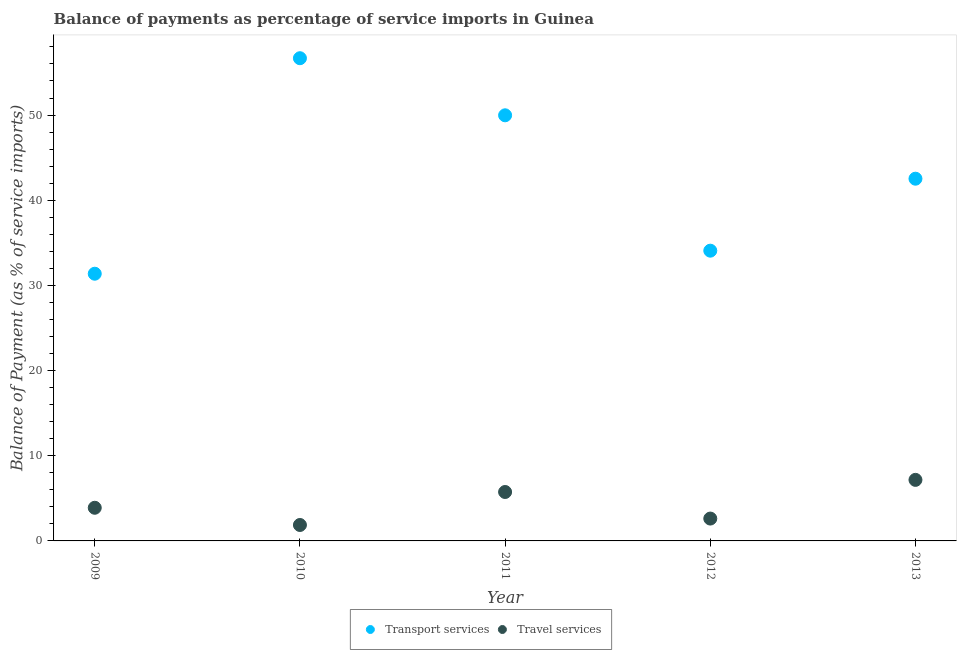How many different coloured dotlines are there?
Provide a short and direct response. 2. What is the balance of payments of transport services in 2011?
Offer a very short reply. 49.97. Across all years, what is the maximum balance of payments of travel services?
Offer a terse response. 7.17. Across all years, what is the minimum balance of payments of transport services?
Offer a terse response. 31.37. In which year was the balance of payments of travel services minimum?
Ensure brevity in your answer.  2010. What is the total balance of payments of transport services in the graph?
Keep it short and to the point. 214.62. What is the difference between the balance of payments of travel services in 2011 and that in 2012?
Your response must be concise. 3.12. What is the difference between the balance of payments of travel services in 2010 and the balance of payments of transport services in 2009?
Your answer should be compact. -29.5. What is the average balance of payments of transport services per year?
Keep it short and to the point. 42.92. In the year 2011, what is the difference between the balance of payments of transport services and balance of payments of travel services?
Ensure brevity in your answer.  44.23. What is the ratio of the balance of payments of transport services in 2009 to that in 2010?
Your response must be concise. 0.55. Is the balance of payments of travel services in 2010 less than that in 2011?
Give a very brief answer. Yes. What is the difference between the highest and the second highest balance of payments of transport services?
Give a very brief answer. 6.7. What is the difference between the highest and the lowest balance of payments of transport services?
Keep it short and to the point. 25.3. In how many years, is the balance of payments of transport services greater than the average balance of payments of transport services taken over all years?
Your answer should be compact. 2. Is the sum of the balance of payments of travel services in 2009 and 2010 greater than the maximum balance of payments of transport services across all years?
Your answer should be compact. No. How many dotlines are there?
Offer a terse response. 2. What is the difference between two consecutive major ticks on the Y-axis?
Your response must be concise. 10. Does the graph contain any zero values?
Offer a very short reply. No. Where does the legend appear in the graph?
Give a very brief answer. Bottom center. How many legend labels are there?
Ensure brevity in your answer.  2. What is the title of the graph?
Give a very brief answer. Balance of payments as percentage of service imports in Guinea. Does "Secondary" appear as one of the legend labels in the graph?
Make the answer very short. No. What is the label or title of the X-axis?
Your answer should be very brief. Year. What is the label or title of the Y-axis?
Provide a short and direct response. Balance of Payment (as % of service imports). What is the Balance of Payment (as % of service imports) of Transport services in 2009?
Keep it short and to the point. 31.37. What is the Balance of Payment (as % of service imports) of Travel services in 2009?
Offer a terse response. 3.89. What is the Balance of Payment (as % of service imports) of Transport services in 2010?
Offer a terse response. 56.67. What is the Balance of Payment (as % of service imports) in Travel services in 2010?
Provide a short and direct response. 1.87. What is the Balance of Payment (as % of service imports) of Transport services in 2011?
Ensure brevity in your answer.  49.97. What is the Balance of Payment (as % of service imports) of Travel services in 2011?
Your response must be concise. 5.74. What is the Balance of Payment (as % of service imports) of Transport services in 2012?
Offer a very short reply. 34.08. What is the Balance of Payment (as % of service imports) of Travel services in 2012?
Provide a succinct answer. 2.63. What is the Balance of Payment (as % of service imports) in Transport services in 2013?
Offer a very short reply. 42.53. What is the Balance of Payment (as % of service imports) of Travel services in 2013?
Make the answer very short. 7.17. Across all years, what is the maximum Balance of Payment (as % of service imports) in Transport services?
Your answer should be very brief. 56.67. Across all years, what is the maximum Balance of Payment (as % of service imports) of Travel services?
Provide a succinct answer. 7.17. Across all years, what is the minimum Balance of Payment (as % of service imports) in Transport services?
Keep it short and to the point. 31.37. Across all years, what is the minimum Balance of Payment (as % of service imports) of Travel services?
Offer a very short reply. 1.87. What is the total Balance of Payment (as % of service imports) in Transport services in the graph?
Offer a terse response. 214.62. What is the total Balance of Payment (as % of service imports) of Travel services in the graph?
Your answer should be very brief. 21.3. What is the difference between the Balance of Payment (as % of service imports) of Transport services in 2009 and that in 2010?
Offer a very short reply. -25.3. What is the difference between the Balance of Payment (as % of service imports) of Travel services in 2009 and that in 2010?
Offer a terse response. 2.02. What is the difference between the Balance of Payment (as % of service imports) of Transport services in 2009 and that in 2011?
Offer a very short reply. -18.6. What is the difference between the Balance of Payment (as % of service imports) of Travel services in 2009 and that in 2011?
Your answer should be compact. -1.85. What is the difference between the Balance of Payment (as % of service imports) of Transport services in 2009 and that in 2012?
Give a very brief answer. -2.71. What is the difference between the Balance of Payment (as % of service imports) of Travel services in 2009 and that in 2012?
Provide a succinct answer. 1.27. What is the difference between the Balance of Payment (as % of service imports) in Transport services in 2009 and that in 2013?
Your response must be concise. -11.16. What is the difference between the Balance of Payment (as % of service imports) in Travel services in 2009 and that in 2013?
Ensure brevity in your answer.  -3.27. What is the difference between the Balance of Payment (as % of service imports) of Transport services in 2010 and that in 2011?
Give a very brief answer. 6.7. What is the difference between the Balance of Payment (as % of service imports) of Travel services in 2010 and that in 2011?
Offer a very short reply. -3.87. What is the difference between the Balance of Payment (as % of service imports) in Transport services in 2010 and that in 2012?
Ensure brevity in your answer.  22.6. What is the difference between the Balance of Payment (as % of service imports) of Travel services in 2010 and that in 2012?
Make the answer very short. -0.75. What is the difference between the Balance of Payment (as % of service imports) of Transport services in 2010 and that in 2013?
Your answer should be very brief. 14.15. What is the difference between the Balance of Payment (as % of service imports) of Travel services in 2010 and that in 2013?
Keep it short and to the point. -5.3. What is the difference between the Balance of Payment (as % of service imports) in Transport services in 2011 and that in 2012?
Your answer should be compact. 15.89. What is the difference between the Balance of Payment (as % of service imports) in Travel services in 2011 and that in 2012?
Provide a succinct answer. 3.12. What is the difference between the Balance of Payment (as % of service imports) in Transport services in 2011 and that in 2013?
Your answer should be very brief. 7.44. What is the difference between the Balance of Payment (as % of service imports) in Travel services in 2011 and that in 2013?
Give a very brief answer. -1.42. What is the difference between the Balance of Payment (as % of service imports) in Transport services in 2012 and that in 2013?
Your answer should be compact. -8.45. What is the difference between the Balance of Payment (as % of service imports) of Travel services in 2012 and that in 2013?
Offer a terse response. -4.54. What is the difference between the Balance of Payment (as % of service imports) in Transport services in 2009 and the Balance of Payment (as % of service imports) in Travel services in 2010?
Ensure brevity in your answer.  29.5. What is the difference between the Balance of Payment (as % of service imports) in Transport services in 2009 and the Balance of Payment (as % of service imports) in Travel services in 2011?
Give a very brief answer. 25.63. What is the difference between the Balance of Payment (as % of service imports) in Transport services in 2009 and the Balance of Payment (as % of service imports) in Travel services in 2012?
Provide a succinct answer. 28.75. What is the difference between the Balance of Payment (as % of service imports) of Transport services in 2009 and the Balance of Payment (as % of service imports) of Travel services in 2013?
Provide a short and direct response. 24.2. What is the difference between the Balance of Payment (as % of service imports) of Transport services in 2010 and the Balance of Payment (as % of service imports) of Travel services in 2011?
Your answer should be very brief. 50.93. What is the difference between the Balance of Payment (as % of service imports) of Transport services in 2010 and the Balance of Payment (as % of service imports) of Travel services in 2012?
Give a very brief answer. 54.05. What is the difference between the Balance of Payment (as % of service imports) of Transport services in 2010 and the Balance of Payment (as % of service imports) of Travel services in 2013?
Offer a terse response. 49.51. What is the difference between the Balance of Payment (as % of service imports) of Transport services in 2011 and the Balance of Payment (as % of service imports) of Travel services in 2012?
Your response must be concise. 47.35. What is the difference between the Balance of Payment (as % of service imports) of Transport services in 2011 and the Balance of Payment (as % of service imports) of Travel services in 2013?
Offer a very short reply. 42.8. What is the difference between the Balance of Payment (as % of service imports) in Transport services in 2012 and the Balance of Payment (as % of service imports) in Travel services in 2013?
Offer a terse response. 26.91. What is the average Balance of Payment (as % of service imports) of Transport services per year?
Ensure brevity in your answer.  42.92. What is the average Balance of Payment (as % of service imports) of Travel services per year?
Your answer should be very brief. 4.26. In the year 2009, what is the difference between the Balance of Payment (as % of service imports) in Transport services and Balance of Payment (as % of service imports) in Travel services?
Give a very brief answer. 27.48. In the year 2010, what is the difference between the Balance of Payment (as % of service imports) in Transport services and Balance of Payment (as % of service imports) in Travel services?
Your answer should be compact. 54.8. In the year 2011, what is the difference between the Balance of Payment (as % of service imports) of Transport services and Balance of Payment (as % of service imports) of Travel services?
Offer a terse response. 44.23. In the year 2012, what is the difference between the Balance of Payment (as % of service imports) in Transport services and Balance of Payment (as % of service imports) in Travel services?
Ensure brevity in your answer.  31.45. In the year 2013, what is the difference between the Balance of Payment (as % of service imports) of Transport services and Balance of Payment (as % of service imports) of Travel services?
Your response must be concise. 35.36. What is the ratio of the Balance of Payment (as % of service imports) in Transport services in 2009 to that in 2010?
Your response must be concise. 0.55. What is the ratio of the Balance of Payment (as % of service imports) in Travel services in 2009 to that in 2010?
Provide a short and direct response. 2.08. What is the ratio of the Balance of Payment (as % of service imports) of Transport services in 2009 to that in 2011?
Ensure brevity in your answer.  0.63. What is the ratio of the Balance of Payment (as % of service imports) in Travel services in 2009 to that in 2011?
Provide a succinct answer. 0.68. What is the ratio of the Balance of Payment (as % of service imports) of Transport services in 2009 to that in 2012?
Your answer should be compact. 0.92. What is the ratio of the Balance of Payment (as % of service imports) in Travel services in 2009 to that in 2012?
Keep it short and to the point. 1.48. What is the ratio of the Balance of Payment (as % of service imports) in Transport services in 2009 to that in 2013?
Your answer should be very brief. 0.74. What is the ratio of the Balance of Payment (as % of service imports) of Travel services in 2009 to that in 2013?
Your response must be concise. 0.54. What is the ratio of the Balance of Payment (as % of service imports) in Transport services in 2010 to that in 2011?
Offer a terse response. 1.13. What is the ratio of the Balance of Payment (as % of service imports) of Travel services in 2010 to that in 2011?
Offer a terse response. 0.33. What is the ratio of the Balance of Payment (as % of service imports) of Transport services in 2010 to that in 2012?
Provide a succinct answer. 1.66. What is the ratio of the Balance of Payment (as % of service imports) of Travel services in 2010 to that in 2012?
Ensure brevity in your answer.  0.71. What is the ratio of the Balance of Payment (as % of service imports) of Transport services in 2010 to that in 2013?
Ensure brevity in your answer.  1.33. What is the ratio of the Balance of Payment (as % of service imports) of Travel services in 2010 to that in 2013?
Keep it short and to the point. 0.26. What is the ratio of the Balance of Payment (as % of service imports) of Transport services in 2011 to that in 2012?
Your answer should be very brief. 1.47. What is the ratio of the Balance of Payment (as % of service imports) of Travel services in 2011 to that in 2012?
Ensure brevity in your answer.  2.19. What is the ratio of the Balance of Payment (as % of service imports) of Transport services in 2011 to that in 2013?
Your answer should be compact. 1.18. What is the ratio of the Balance of Payment (as % of service imports) of Travel services in 2011 to that in 2013?
Ensure brevity in your answer.  0.8. What is the ratio of the Balance of Payment (as % of service imports) of Transport services in 2012 to that in 2013?
Offer a very short reply. 0.8. What is the ratio of the Balance of Payment (as % of service imports) of Travel services in 2012 to that in 2013?
Your response must be concise. 0.37. What is the difference between the highest and the second highest Balance of Payment (as % of service imports) in Transport services?
Keep it short and to the point. 6.7. What is the difference between the highest and the second highest Balance of Payment (as % of service imports) in Travel services?
Your answer should be compact. 1.42. What is the difference between the highest and the lowest Balance of Payment (as % of service imports) in Transport services?
Offer a terse response. 25.3. What is the difference between the highest and the lowest Balance of Payment (as % of service imports) in Travel services?
Your answer should be compact. 5.3. 